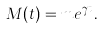<formula> <loc_0><loc_0><loc_500><loc_500>M ( t ) = m e ^ { \gamma t } .</formula> 